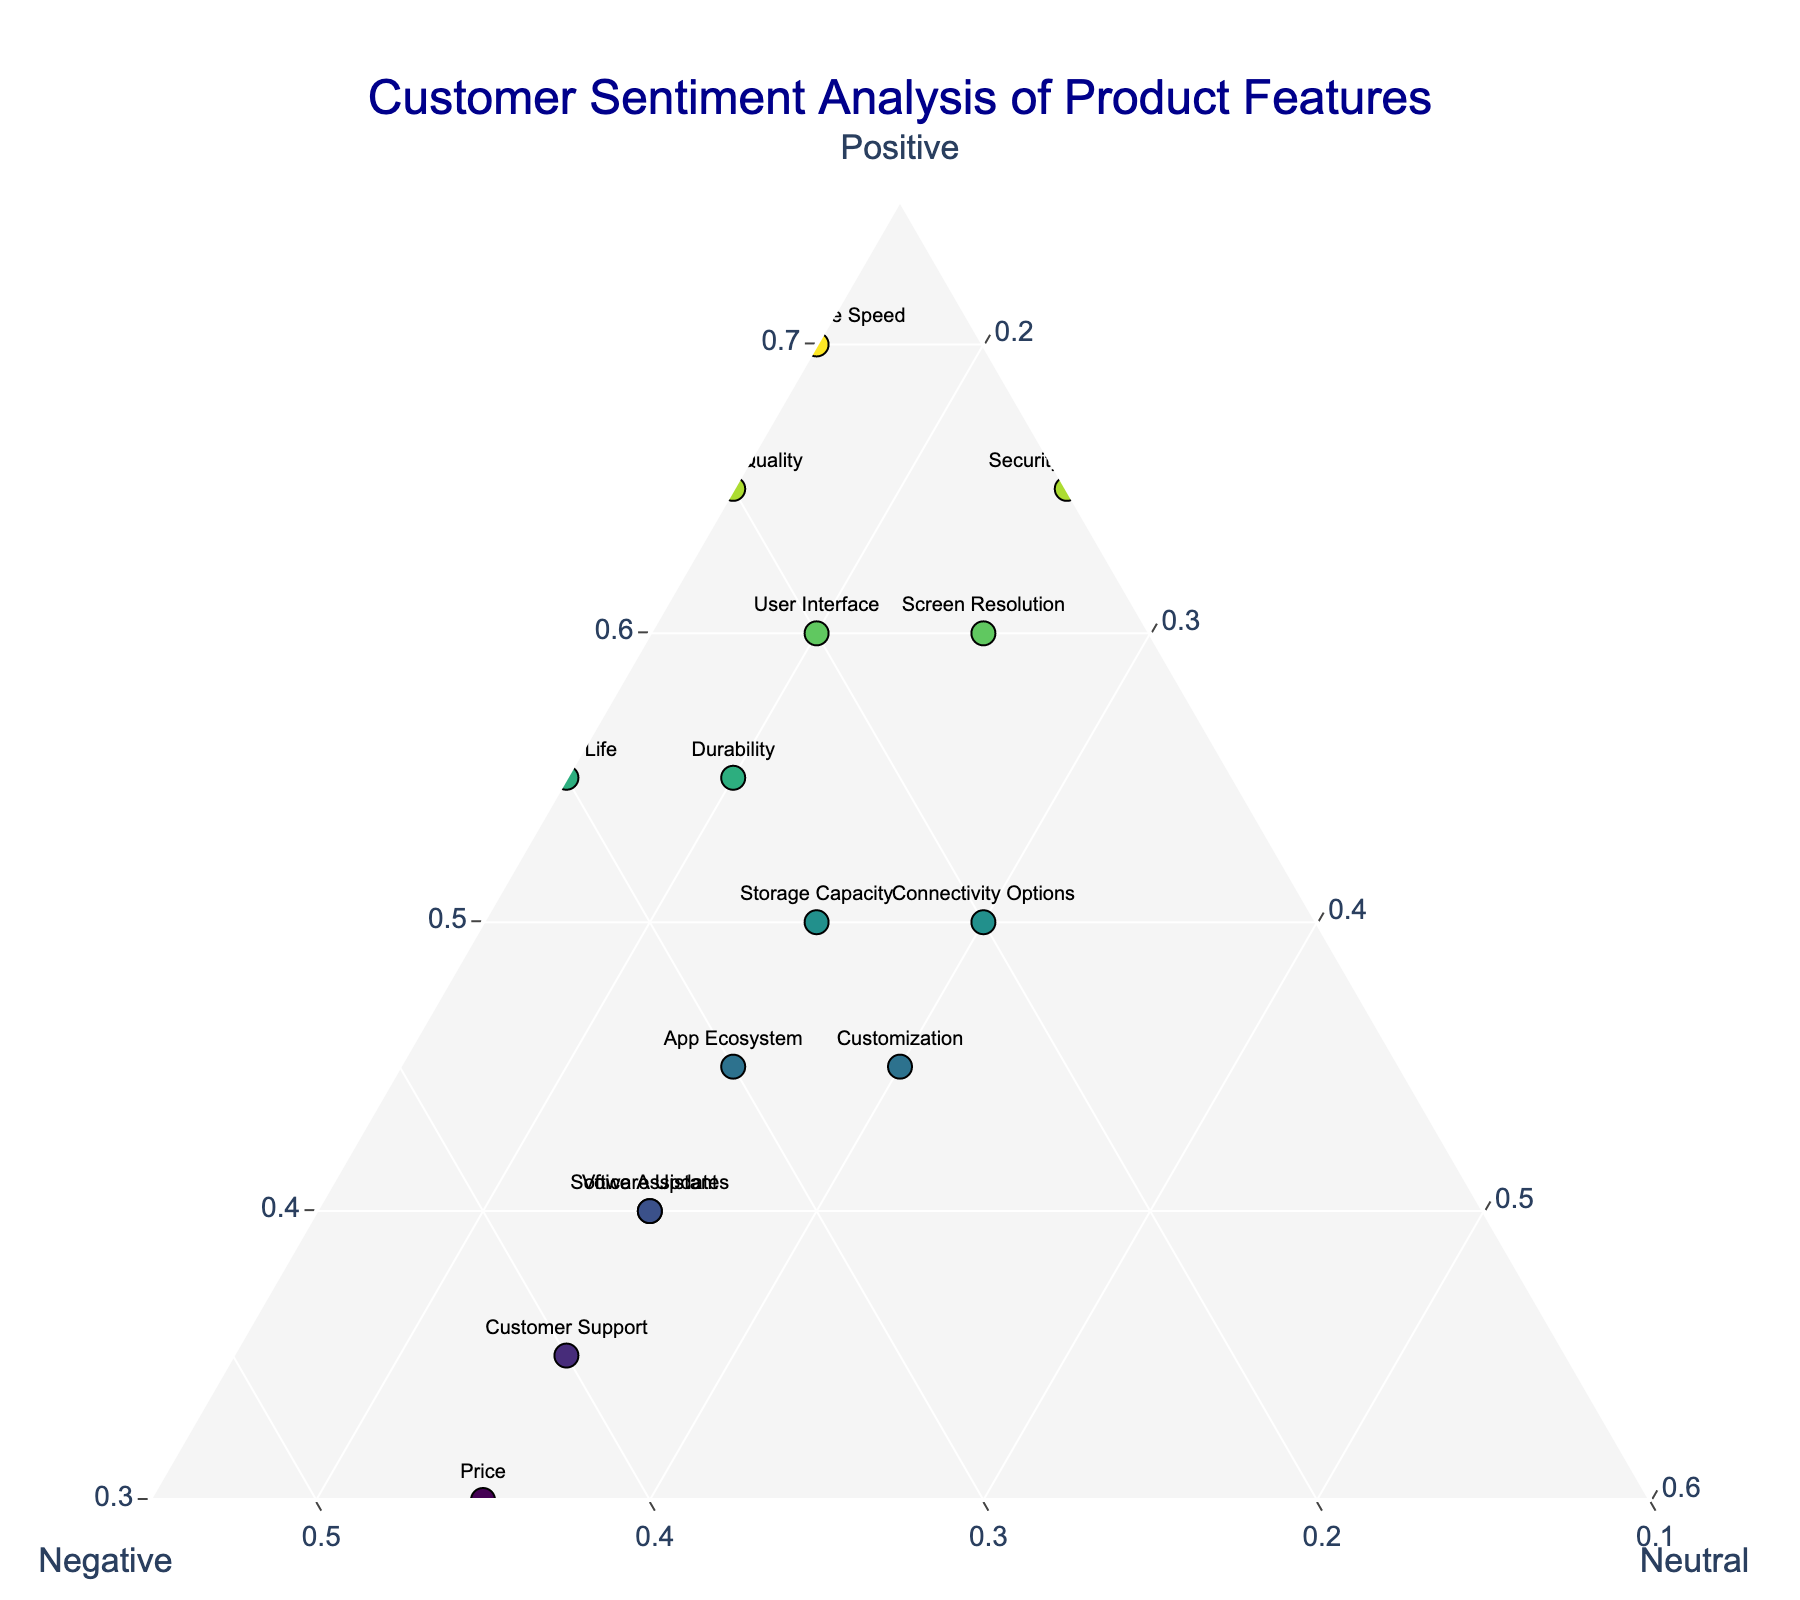What feature has the highest positive sentiment? The point farthest toward the 'Positive' axis indicates the feature with the highest positive sentiment, which is the one with the highest normalized value for Positive. The 'Performance Speed' is nearest to Positive axis.
Answer: Performance Speed Which feature has the highest negative sentiment? The point farthest toward the 'Negative' axis indicates the feature with the highest negative sentiment. The 'Price' feature is closest to the 'Negative' axis.
Answer: Price What is the approximate range of neutral sentiment values observed? The neutral sentiment values range from 0.15 to 0.30. This can be observed by looking at the spread of the data points along the Neutral axis.
Answer: 0.15 to 0.30 Which feature has a sentiment distribution where positive is roughly equal to the sum of negative and neutral? Locate the point where the value of Positive is approximately equal to the combined values of Negative and Neutral. For 'User Interface', the sentiment values are approximately balanced, with 0.6 for Positive and 0.4 for Negative + Neutral.
Answer: User Interface How does Voice Assistant compare to Durability in terms of negative sentiment? Compare the positions of the points for 'Voice Assistant' and 'Durability' along the Negative axis. Voice Assistant has a higher negative sentiment than Durability.
Answer: Voice Assistant has higher negative sentiment Which feature has the highest neutral sentiment? The point farthest toward the 'Neutral' axis indicates the feature with the highest neutral sentiment. 'Connectivity Options' is closest to the Neutral axis.
Answer: Connectivity Options Which feature is showing a balanced distribution across all three sentiments? Look for the point that is located somewhat centrally in the ternary plot, where Positive, Negative, and Neutral sentiments are roughly equal. 'Storage Capacity' has sentiment values closest to being balanced.
Answer: Storage Capacity Which feature has the lowest positive sentiment? The point farthest from the 'Positive' axis, and closest toward other two axes, reflects the lowest positive sentiment, which is 'Price'.
Answer: Price How does the sentiment of Security Features compare to Camera Quality? Compare the positions for 'Security Features' and 'Camera Quality' across the Positive, Negative, and Neutral axes. Security Features have higher positive and lower negative sentiment compared to Camera Quality.
Answer: Security Features have higher positive and lower negative What observation can you make about Customer Support compared to other features? Customer Support appears relatively high in negative sentiment. It's far from the Positive axis and closer to the Negative axis compared to many other features.
Answer: Higher negative sentiment 